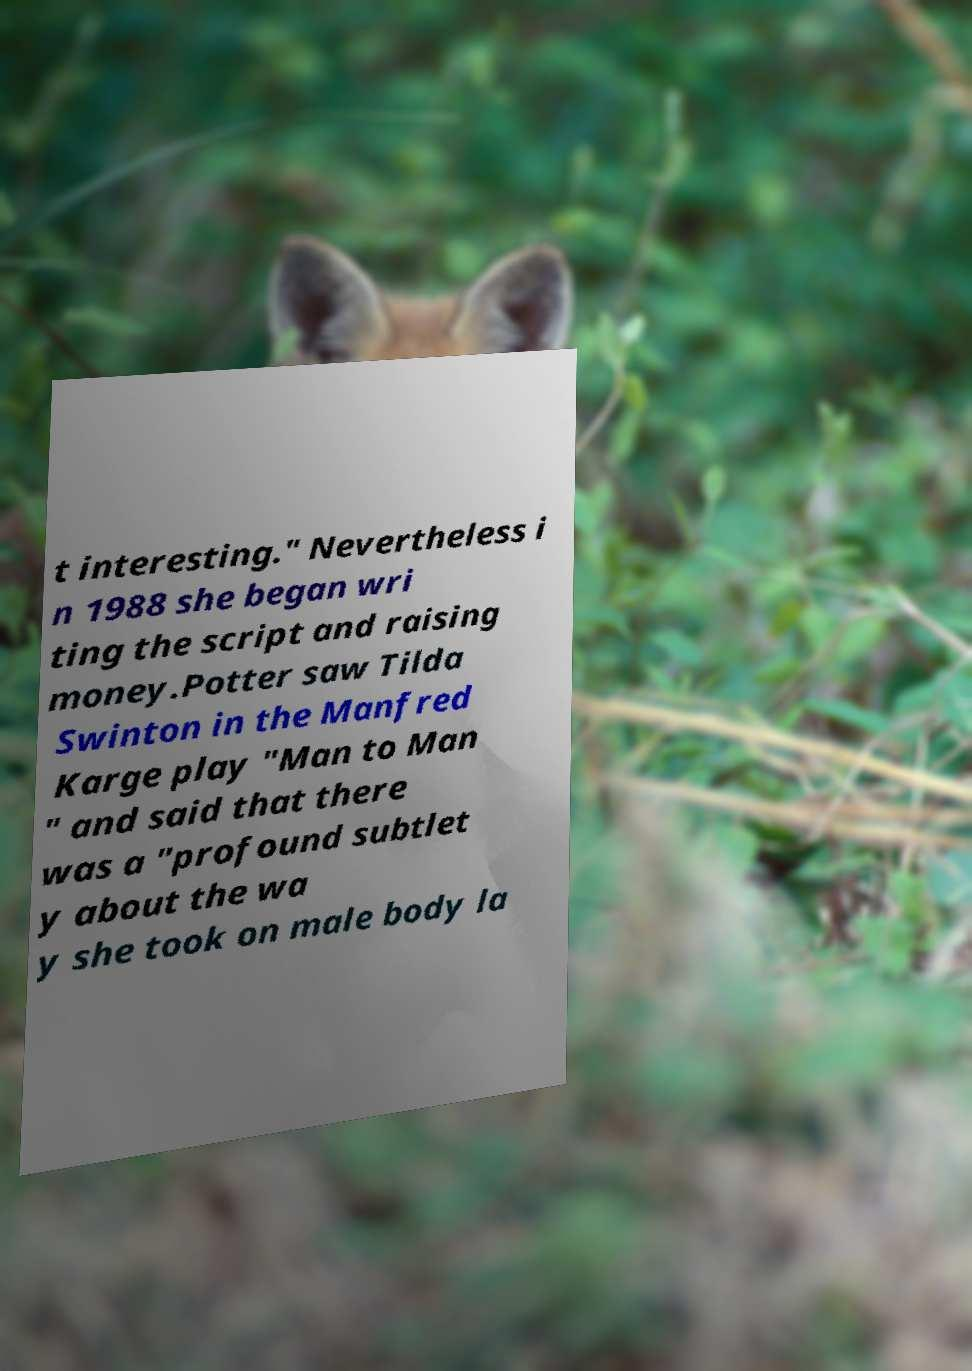Please identify and transcribe the text found in this image. t interesting." Nevertheless i n 1988 she began wri ting the script and raising money.Potter saw Tilda Swinton in the Manfred Karge play "Man to Man " and said that there was a "profound subtlet y about the wa y she took on male body la 